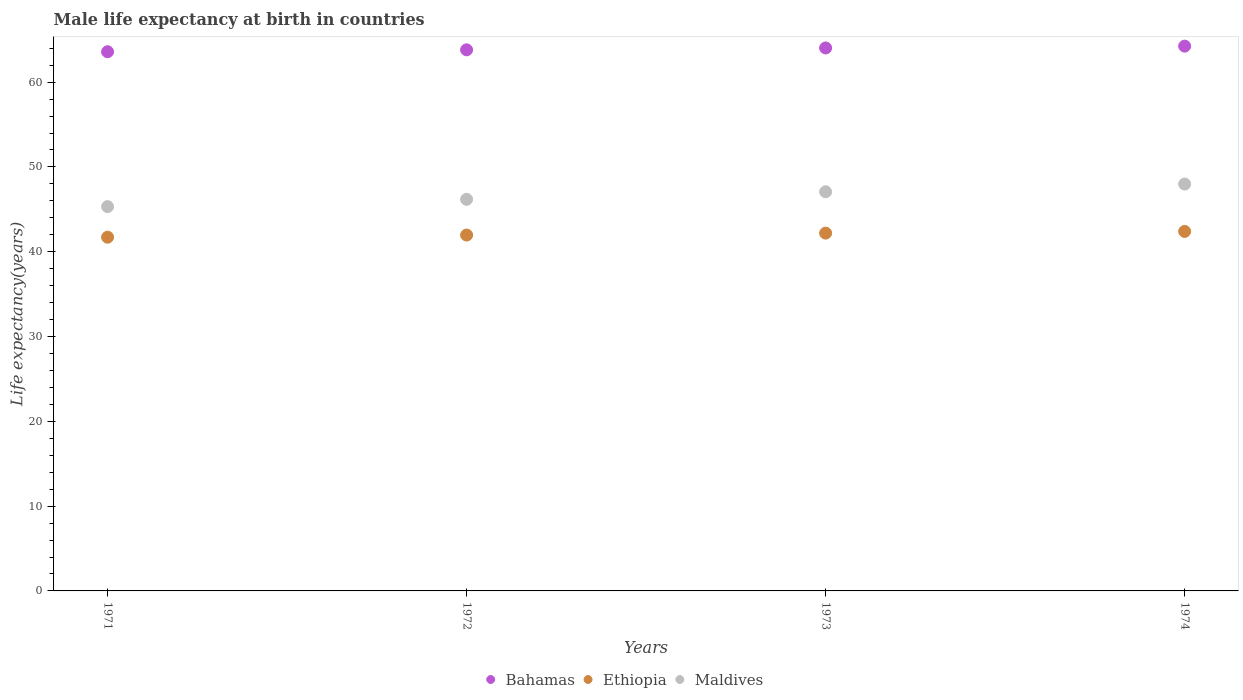Is the number of dotlines equal to the number of legend labels?
Your answer should be compact. Yes. What is the male life expectancy at birth in Maldives in 1973?
Ensure brevity in your answer.  47.07. Across all years, what is the maximum male life expectancy at birth in Maldives?
Ensure brevity in your answer.  47.99. Across all years, what is the minimum male life expectancy at birth in Bahamas?
Your answer should be very brief. 63.59. In which year was the male life expectancy at birth in Ethiopia maximum?
Ensure brevity in your answer.  1974. In which year was the male life expectancy at birth in Ethiopia minimum?
Your answer should be very brief. 1971. What is the total male life expectancy at birth in Ethiopia in the graph?
Make the answer very short. 168.28. What is the difference between the male life expectancy at birth in Ethiopia in 1973 and that in 1974?
Your answer should be very brief. -0.2. What is the difference between the male life expectancy at birth in Bahamas in 1972 and the male life expectancy at birth in Ethiopia in 1974?
Make the answer very short. 21.41. What is the average male life expectancy at birth in Ethiopia per year?
Ensure brevity in your answer.  42.07. In the year 1971, what is the difference between the male life expectancy at birth in Maldives and male life expectancy at birth in Ethiopia?
Offer a very short reply. 3.6. What is the ratio of the male life expectancy at birth in Ethiopia in 1971 to that in 1973?
Make the answer very short. 0.99. Is the male life expectancy at birth in Maldives in 1973 less than that in 1974?
Your answer should be compact. Yes. What is the difference between the highest and the second highest male life expectancy at birth in Ethiopia?
Ensure brevity in your answer.  0.2. What is the difference between the highest and the lowest male life expectancy at birth in Maldives?
Offer a terse response. 2.67. In how many years, is the male life expectancy at birth in Bahamas greater than the average male life expectancy at birth in Bahamas taken over all years?
Offer a terse response. 2. Does the male life expectancy at birth in Maldives monotonically increase over the years?
Offer a terse response. Yes. Is the male life expectancy at birth in Ethiopia strictly greater than the male life expectancy at birth in Maldives over the years?
Provide a short and direct response. No. Does the graph contain grids?
Provide a succinct answer. No. What is the title of the graph?
Offer a terse response. Male life expectancy at birth in countries. Does "Latin America(developing only)" appear as one of the legend labels in the graph?
Your response must be concise. No. What is the label or title of the Y-axis?
Your answer should be compact. Life expectancy(years). What is the Life expectancy(years) in Bahamas in 1971?
Give a very brief answer. 63.59. What is the Life expectancy(years) in Ethiopia in 1971?
Offer a very short reply. 41.72. What is the Life expectancy(years) of Maldives in 1971?
Provide a short and direct response. 45.32. What is the Life expectancy(years) in Bahamas in 1972?
Your answer should be very brief. 63.81. What is the Life expectancy(years) of Ethiopia in 1972?
Provide a short and direct response. 41.97. What is the Life expectancy(years) of Maldives in 1972?
Your answer should be compact. 46.18. What is the Life expectancy(years) of Bahamas in 1973?
Your answer should be very brief. 64.03. What is the Life expectancy(years) of Ethiopia in 1973?
Keep it short and to the point. 42.2. What is the Life expectancy(years) in Maldives in 1973?
Keep it short and to the point. 47.07. What is the Life expectancy(years) of Bahamas in 1974?
Provide a succinct answer. 64.25. What is the Life expectancy(years) in Ethiopia in 1974?
Offer a very short reply. 42.4. What is the Life expectancy(years) of Maldives in 1974?
Give a very brief answer. 47.99. Across all years, what is the maximum Life expectancy(years) of Bahamas?
Your response must be concise. 64.25. Across all years, what is the maximum Life expectancy(years) of Ethiopia?
Your response must be concise. 42.4. Across all years, what is the maximum Life expectancy(years) in Maldives?
Your answer should be very brief. 47.99. Across all years, what is the minimum Life expectancy(years) of Bahamas?
Your answer should be compact. 63.59. Across all years, what is the minimum Life expectancy(years) in Ethiopia?
Offer a terse response. 41.72. Across all years, what is the minimum Life expectancy(years) of Maldives?
Offer a terse response. 45.32. What is the total Life expectancy(years) of Bahamas in the graph?
Make the answer very short. 255.68. What is the total Life expectancy(years) of Ethiopia in the graph?
Keep it short and to the point. 168.28. What is the total Life expectancy(years) of Maldives in the graph?
Keep it short and to the point. 186.56. What is the difference between the Life expectancy(years) of Bahamas in 1971 and that in 1972?
Make the answer very short. -0.23. What is the difference between the Life expectancy(years) of Ethiopia in 1971 and that in 1972?
Offer a terse response. -0.25. What is the difference between the Life expectancy(years) of Maldives in 1971 and that in 1972?
Provide a short and direct response. -0.86. What is the difference between the Life expectancy(years) of Bahamas in 1971 and that in 1973?
Your answer should be very brief. -0.45. What is the difference between the Life expectancy(years) of Ethiopia in 1971 and that in 1973?
Provide a short and direct response. -0.48. What is the difference between the Life expectancy(years) of Maldives in 1971 and that in 1973?
Ensure brevity in your answer.  -1.75. What is the difference between the Life expectancy(years) in Bahamas in 1971 and that in 1974?
Your answer should be very brief. -0.66. What is the difference between the Life expectancy(years) in Ethiopia in 1971 and that in 1974?
Keep it short and to the point. -0.68. What is the difference between the Life expectancy(years) in Maldives in 1971 and that in 1974?
Give a very brief answer. -2.67. What is the difference between the Life expectancy(years) of Bahamas in 1972 and that in 1973?
Keep it short and to the point. -0.22. What is the difference between the Life expectancy(years) of Ethiopia in 1972 and that in 1973?
Your response must be concise. -0.23. What is the difference between the Life expectancy(years) in Maldives in 1972 and that in 1973?
Provide a short and direct response. -0.89. What is the difference between the Life expectancy(years) in Bahamas in 1972 and that in 1974?
Give a very brief answer. -0.44. What is the difference between the Life expectancy(years) in Ethiopia in 1972 and that in 1974?
Offer a terse response. -0.43. What is the difference between the Life expectancy(years) of Maldives in 1972 and that in 1974?
Provide a succinct answer. -1.8. What is the difference between the Life expectancy(years) in Bahamas in 1973 and that in 1974?
Offer a terse response. -0.22. What is the difference between the Life expectancy(years) in Ethiopia in 1973 and that in 1974?
Keep it short and to the point. -0.2. What is the difference between the Life expectancy(years) in Maldives in 1973 and that in 1974?
Ensure brevity in your answer.  -0.92. What is the difference between the Life expectancy(years) of Bahamas in 1971 and the Life expectancy(years) of Ethiopia in 1972?
Provide a short and direct response. 21.62. What is the difference between the Life expectancy(years) of Bahamas in 1971 and the Life expectancy(years) of Maldives in 1972?
Your answer should be very brief. 17.41. What is the difference between the Life expectancy(years) in Ethiopia in 1971 and the Life expectancy(years) in Maldives in 1972?
Offer a very short reply. -4.47. What is the difference between the Life expectancy(years) of Bahamas in 1971 and the Life expectancy(years) of Ethiopia in 1973?
Your response must be concise. 21.39. What is the difference between the Life expectancy(years) in Bahamas in 1971 and the Life expectancy(years) in Maldives in 1973?
Give a very brief answer. 16.52. What is the difference between the Life expectancy(years) in Ethiopia in 1971 and the Life expectancy(years) in Maldives in 1973?
Offer a very short reply. -5.36. What is the difference between the Life expectancy(years) of Bahamas in 1971 and the Life expectancy(years) of Ethiopia in 1974?
Your answer should be very brief. 21.19. What is the difference between the Life expectancy(years) in Bahamas in 1971 and the Life expectancy(years) in Maldives in 1974?
Provide a short and direct response. 15.6. What is the difference between the Life expectancy(years) in Ethiopia in 1971 and the Life expectancy(years) in Maldives in 1974?
Give a very brief answer. -6.27. What is the difference between the Life expectancy(years) in Bahamas in 1972 and the Life expectancy(years) in Ethiopia in 1973?
Your response must be concise. 21.62. What is the difference between the Life expectancy(years) in Bahamas in 1972 and the Life expectancy(years) in Maldives in 1973?
Provide a short and direct response. 16.74. What is the difference between the Life expectancy(years) in Ethiopia in 1972 and the Life expectancy(years) in Maldives in 1973?
Ensure brevity in your answer.  -5.1. What is the difference between the Life expectancy(years) in Bahamas in 1972 and the Life expectancy(years) in Ethiopia in 1974?
Give a very brief answer. 21.41. What is the difference between the Life expectancy(years) of Bahamas in 1972 and the Life expectancy(years) of Maldives in 1974?
Give a very brief answer. 15.83. What is the difference between the Life expectancy(years) of Ethiopia in 1972 and the Life expectancy(years) of Maldives in 1974?
Offer a terse response. -6.02. What is the difference between the Life expectancy(years) in Bahamas in 1973 and the Life expectancy(years) in Ethiopia in 1974?
Your answer should be very brief. 21.64. What is the difference between the Life expectancy(years) in Bahamas in 1973 and the Life expectancy(years) in Maldives in 1974?
Your answer should be very brief. 16.05. What is the difference between the Life expectancy(years) in Ethiopia in 1973 and the Life expectancy(years) in Maldives in 1974?
Provide a short and direct response. -5.79. What is the average Life expectancy(years) of Bahamas per year?
Offer a terse response. 63.92. What is the average Life expectancy(years) in Ethiopia per year?
Your answer should be very brief. 42.07. What is the average Life expectancy(years) in Maldives per year?
Your answer should be very brief. 46.64. In the year 1971, what is the difference between the Life expectancy(years) in Bahamas and Life expectancy(years) in Ethiopia?
Offer a very short reply. 21.87. In the year 1971, what is the difference between the Life expectancy(years) of Bahamas and Life expectancy(years) of Maldives?
Offer a very short reply. 18.27. In the year 1971, what is the difference between the Life expectancy(years) of Ethiopia and Life expectancy(years) of Maldives?
Your answer should be compact. -3.6. In the year 1972, what is the difference between the Life expectancy(years) of Bahamas and Life expectancy(years) of Ethiopia?
Your answer should be compact. 21.84. In the year 1972, what is the difference between the Life expectancy(years) in Bahamas and Life expectancy(years) in Maldives?
Offer a very short reply. 17.63. In the year 1972, what is the difference between the Life expectancy(years) in Ethiopia and Life expectancy(years) in Maldives?
Make the answer very short. -4.21. In the year 1973, what is the difference between the Life expectancy(years) of Bahamas and Life expectancy(years) of Ethiopia?
Give a very brief answer. 21.84. In the year 1973, what is the difference between the Life expectancy(years) of Bahamas and Life expectancy(years) of Maldives?
Give a very brief answer. 16.96. In the year 1973, what is the difference between the Life expectancy(years) in Ethiopia and Life expectancy(years) in Maldives?
Your response must be concise. -4.87. In the year 1974, what is the difference between the Life expectancy(years) of Bahamas and Life expectancy(years) of Ethiopia?
Provide a succinct answer. 21.85. In the year 1974, what is the difference between the Life expectancy(years) in Bahamas and Life expectancy(years) in Maldives?
Your answer should be very brief. 16.26. In the year 1974, what is the difference between the Life expectancy(years) in Ethiopia and Life expectancy(years) in Maldives?
Make the answer very short. -5.59. What is the ratio of the Life expectancy(years) in Ethiopia in 1971 to that in 1972?
Offer a terse response. 0.99. What is the ratio of the Life expectancy(years) of Maldives in 1971 to that in 1972?
Give a very brief answer. 0.98. What is the ratio of the Life expectancy(years) in Maldives in 1971 to that in 1973?
Provide a short and direct response. 0.96. What is the ratio of the Life expectancy(years) of Ethiopia in 1971 to that in 1974?
Offer a terse response. 0.98. What is the ratio of the Life expectancy(years) in Maldives in 1971 to that in 1974?
Make the answer very short. 0.94. What is the ratio of the Life expectancy(years) of Bahamas in 1972 to that in 1973?
Your answer should be compact. 1. What is the ratio of the Life expectancy(years) in Ethiopia in 1972 to that in 1973?
Your answer should be compact. 0.99. What is the ratio of the Life expectancy(years) of Maldives in 1972 to that in 1973?
Make the answer very short. 0.98. What is the ratio of the Life expectancy(years) of Ethiopia in 1972 to that in 1974?
Make the answer very short. 0.99. What is the ratio of the Life expectancy(years) in Maldives in 1972 to that in 1974?
Give a very brief answer. 0.96. What is the ratio of the Life expectancy(years) in Maldives in 1973 to that in 1974?
Your answer should be compact. 0.98. What is the difference between the highest and the second highest Life expectancy(years) of Bahamas?
Give a very brief answer. 0.22. What is the difference between the highest and the second highest Life expectancy(years) of Ethiopia?
Your response must be concise. 0.2. What is the difference between the highest and the second highest Life expectancy(years) of Maldives?
Ensure brevity in your answer.  0.92. What is the difference between the highest and the lowest Life expectancy(years) in Bahamas?
Make the answer very short. 0.66. What is the difference between the highest and the lowest Life expectancy(years) of Ethiopia?
Give a very brief answer. 0.68. What is the difference between the highest and the lowest Life expectancy(years) in Maldives?
Offer a terse response. 2.67. 